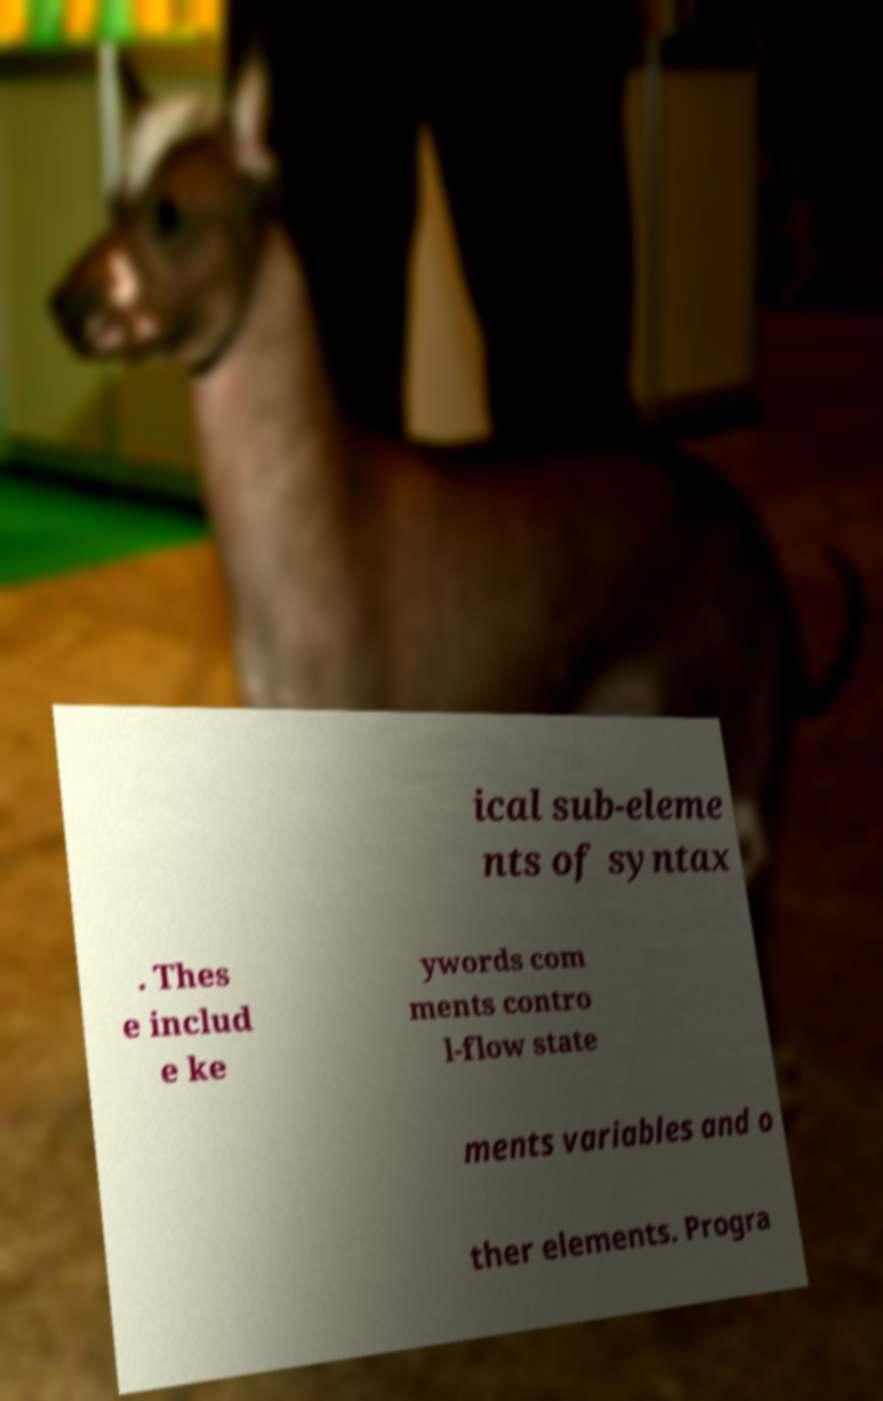Can you accurately transcribe the text from the provided image for me? ical sub-eleme nts of syntax . Thes e includ e ke ywords com ments contro l-flow state ments variables and o ther elements. Progra 